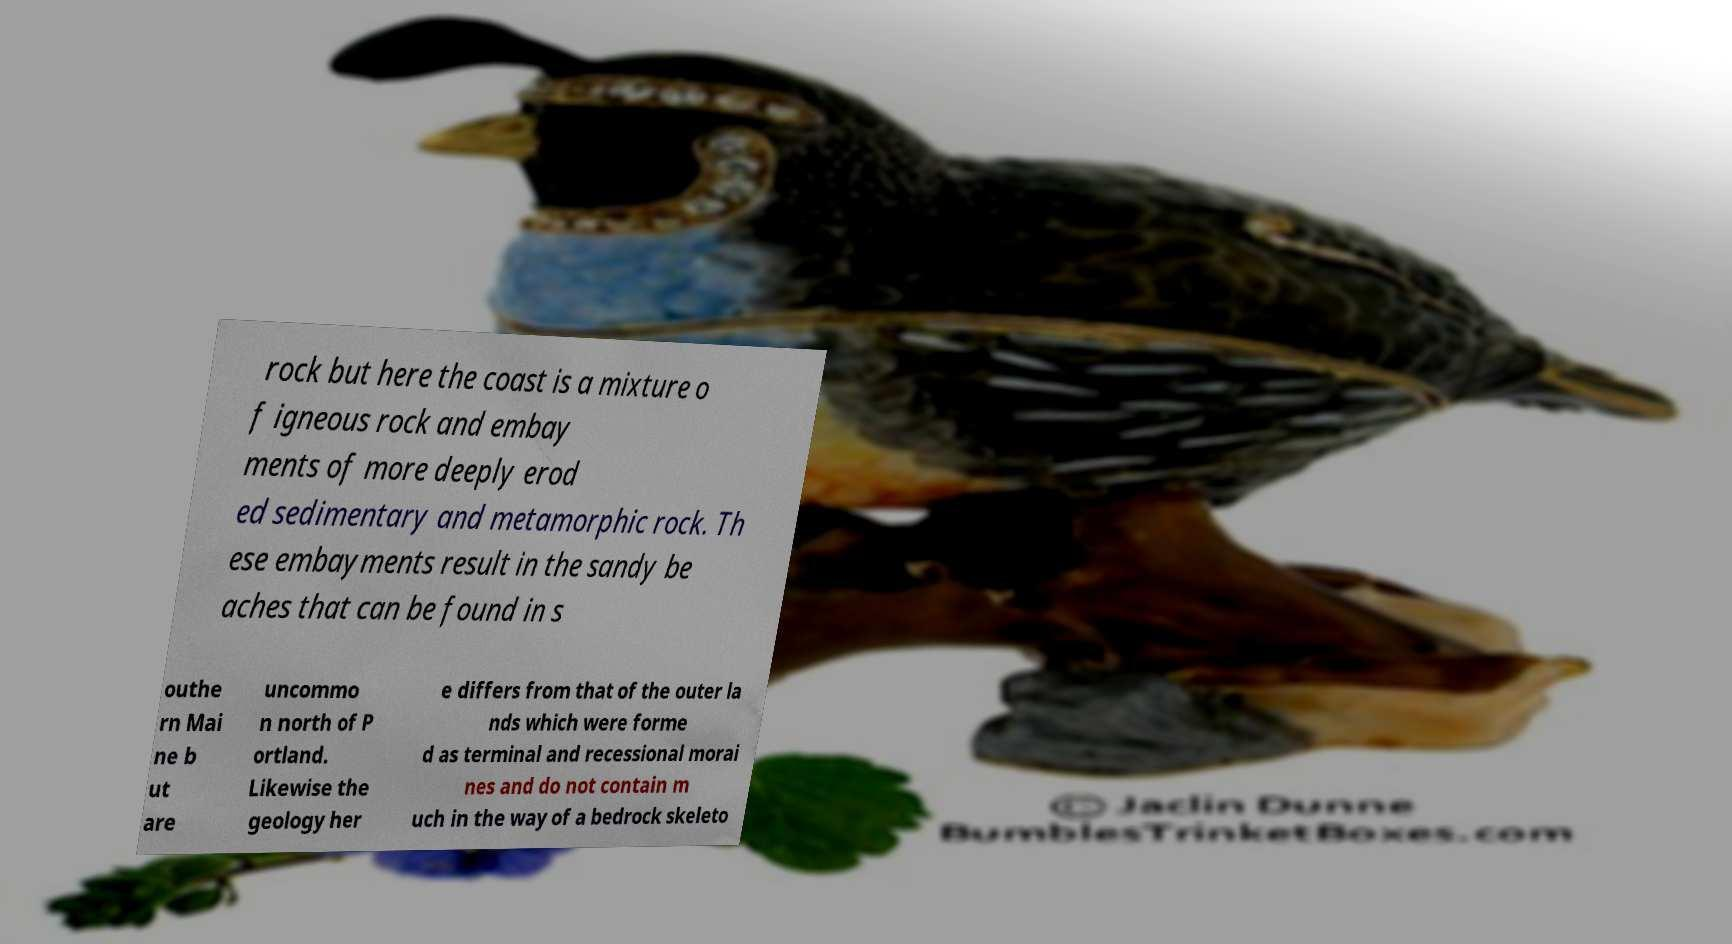For documentation purposes, I need the text within this image transcribed. Could you provide that? rock but here the coast is a mixture o f igneous rock and embay ments of more deeply erod ed sedimentary and metamorphic rock. Th ese embayments result in the sandy be aches that can be found in s outhe rn Mai ne b ut are uncommo n north of P ortland. Likewise the geology her e differs from that of the outer la nds which were forme d as terminal and recessional morai nes and do not contain m uch in the way of a bedrock skeleto 